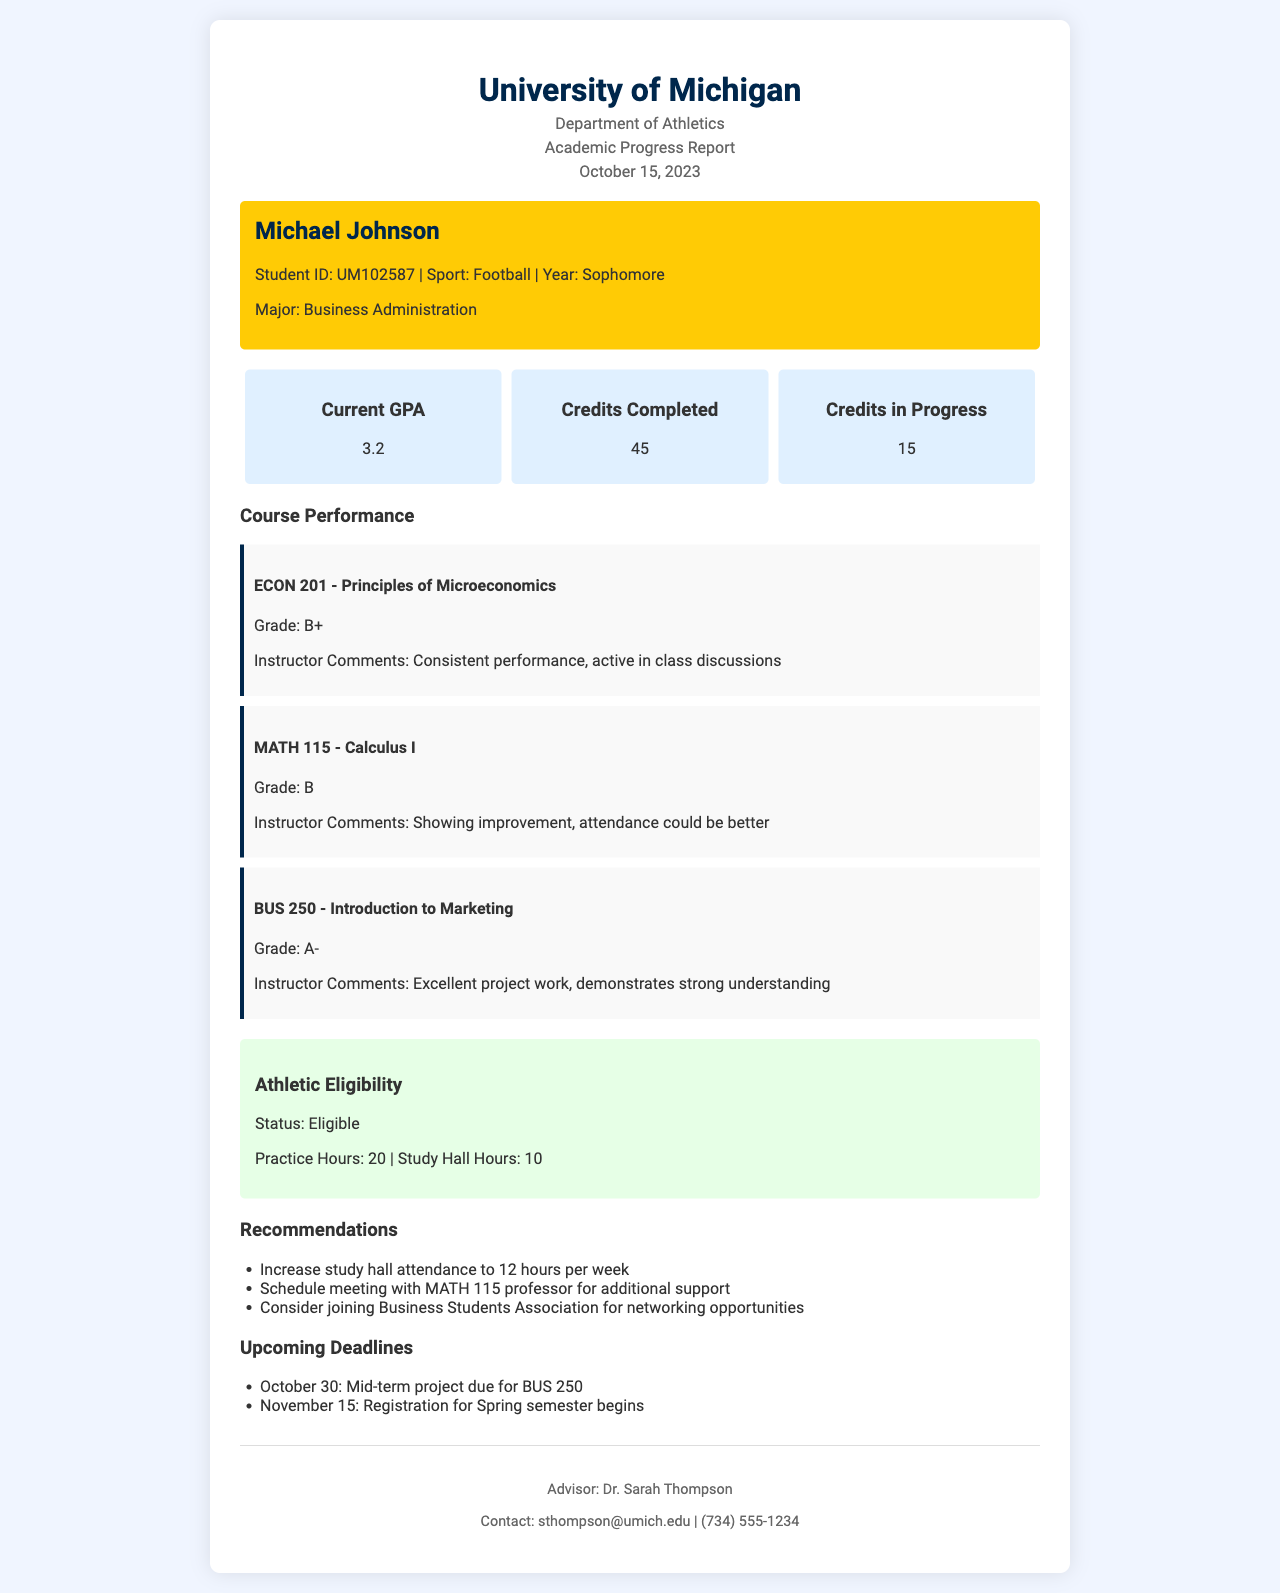What is the student's name? The student's name is mentioned in the document header and student info section.
Answer: Michael Johnson What is the current GPA? The current GPA is provided in the summary section of the document.
Answer: 3.2 How many credits have been completed? The completed credits detail is found in the summary section of the document.
Answer: 45 What is the grade for MATH 115? The grade for MATH 115 is specified in the course performance section along with the instructor comments.
Answer: B What is the status of athletic eligibility? The athletic eligibility status is stated in the eligibility section of the document.
Answer: Eligible What recommendation was given regarding study hall? The recommendations section outlines several suggestions for improvement.
Answer: Increase study hall attendance to 12 hours per week When is the mid-term project due for BUS 250? This deadline is indicated in the upcoming deadlines section of the document.
Answer: October 30 Who is the advisor listed in the document? The advisor's name is given in the footer section of the document.
Answer: Dr. Sarah Thompson How many practice hours are recorded? The practice hours are reported under the athletic eligibility section of the document.
Answer: 20 